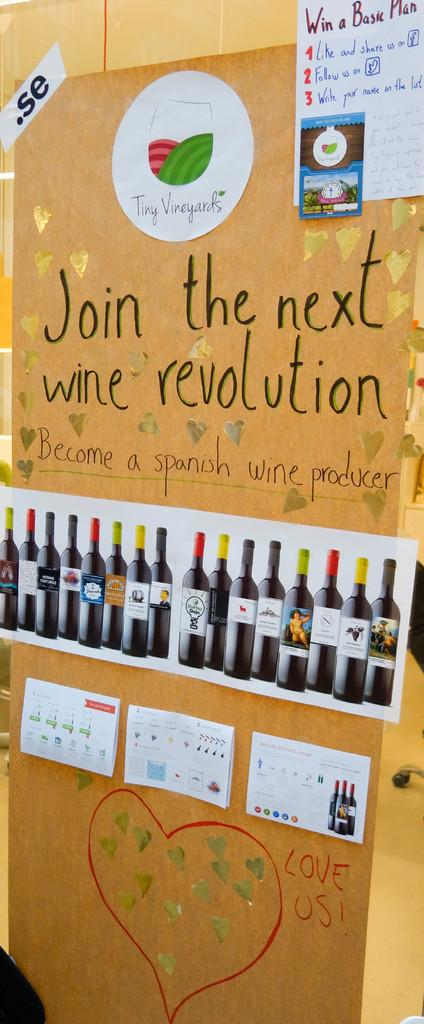<image>
Offer a succinct explanation of the picture presented. A display advertises for people to join the next wine revolution. 